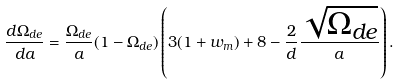<formula> <loc_0><loc_0><loc_500><loc_500>\frac { d \Omega _ { d e } } { d a } = \frac { \Omega _ { d e } } { a } ( 1 - \Omega _ { d e } ) \left ( 3 ( 1 + w _ { m } ) + 8 - \frac { 2 } { d } \frac { \sqrt { \Omega _ { d e } } } a \right ) .</formula> 